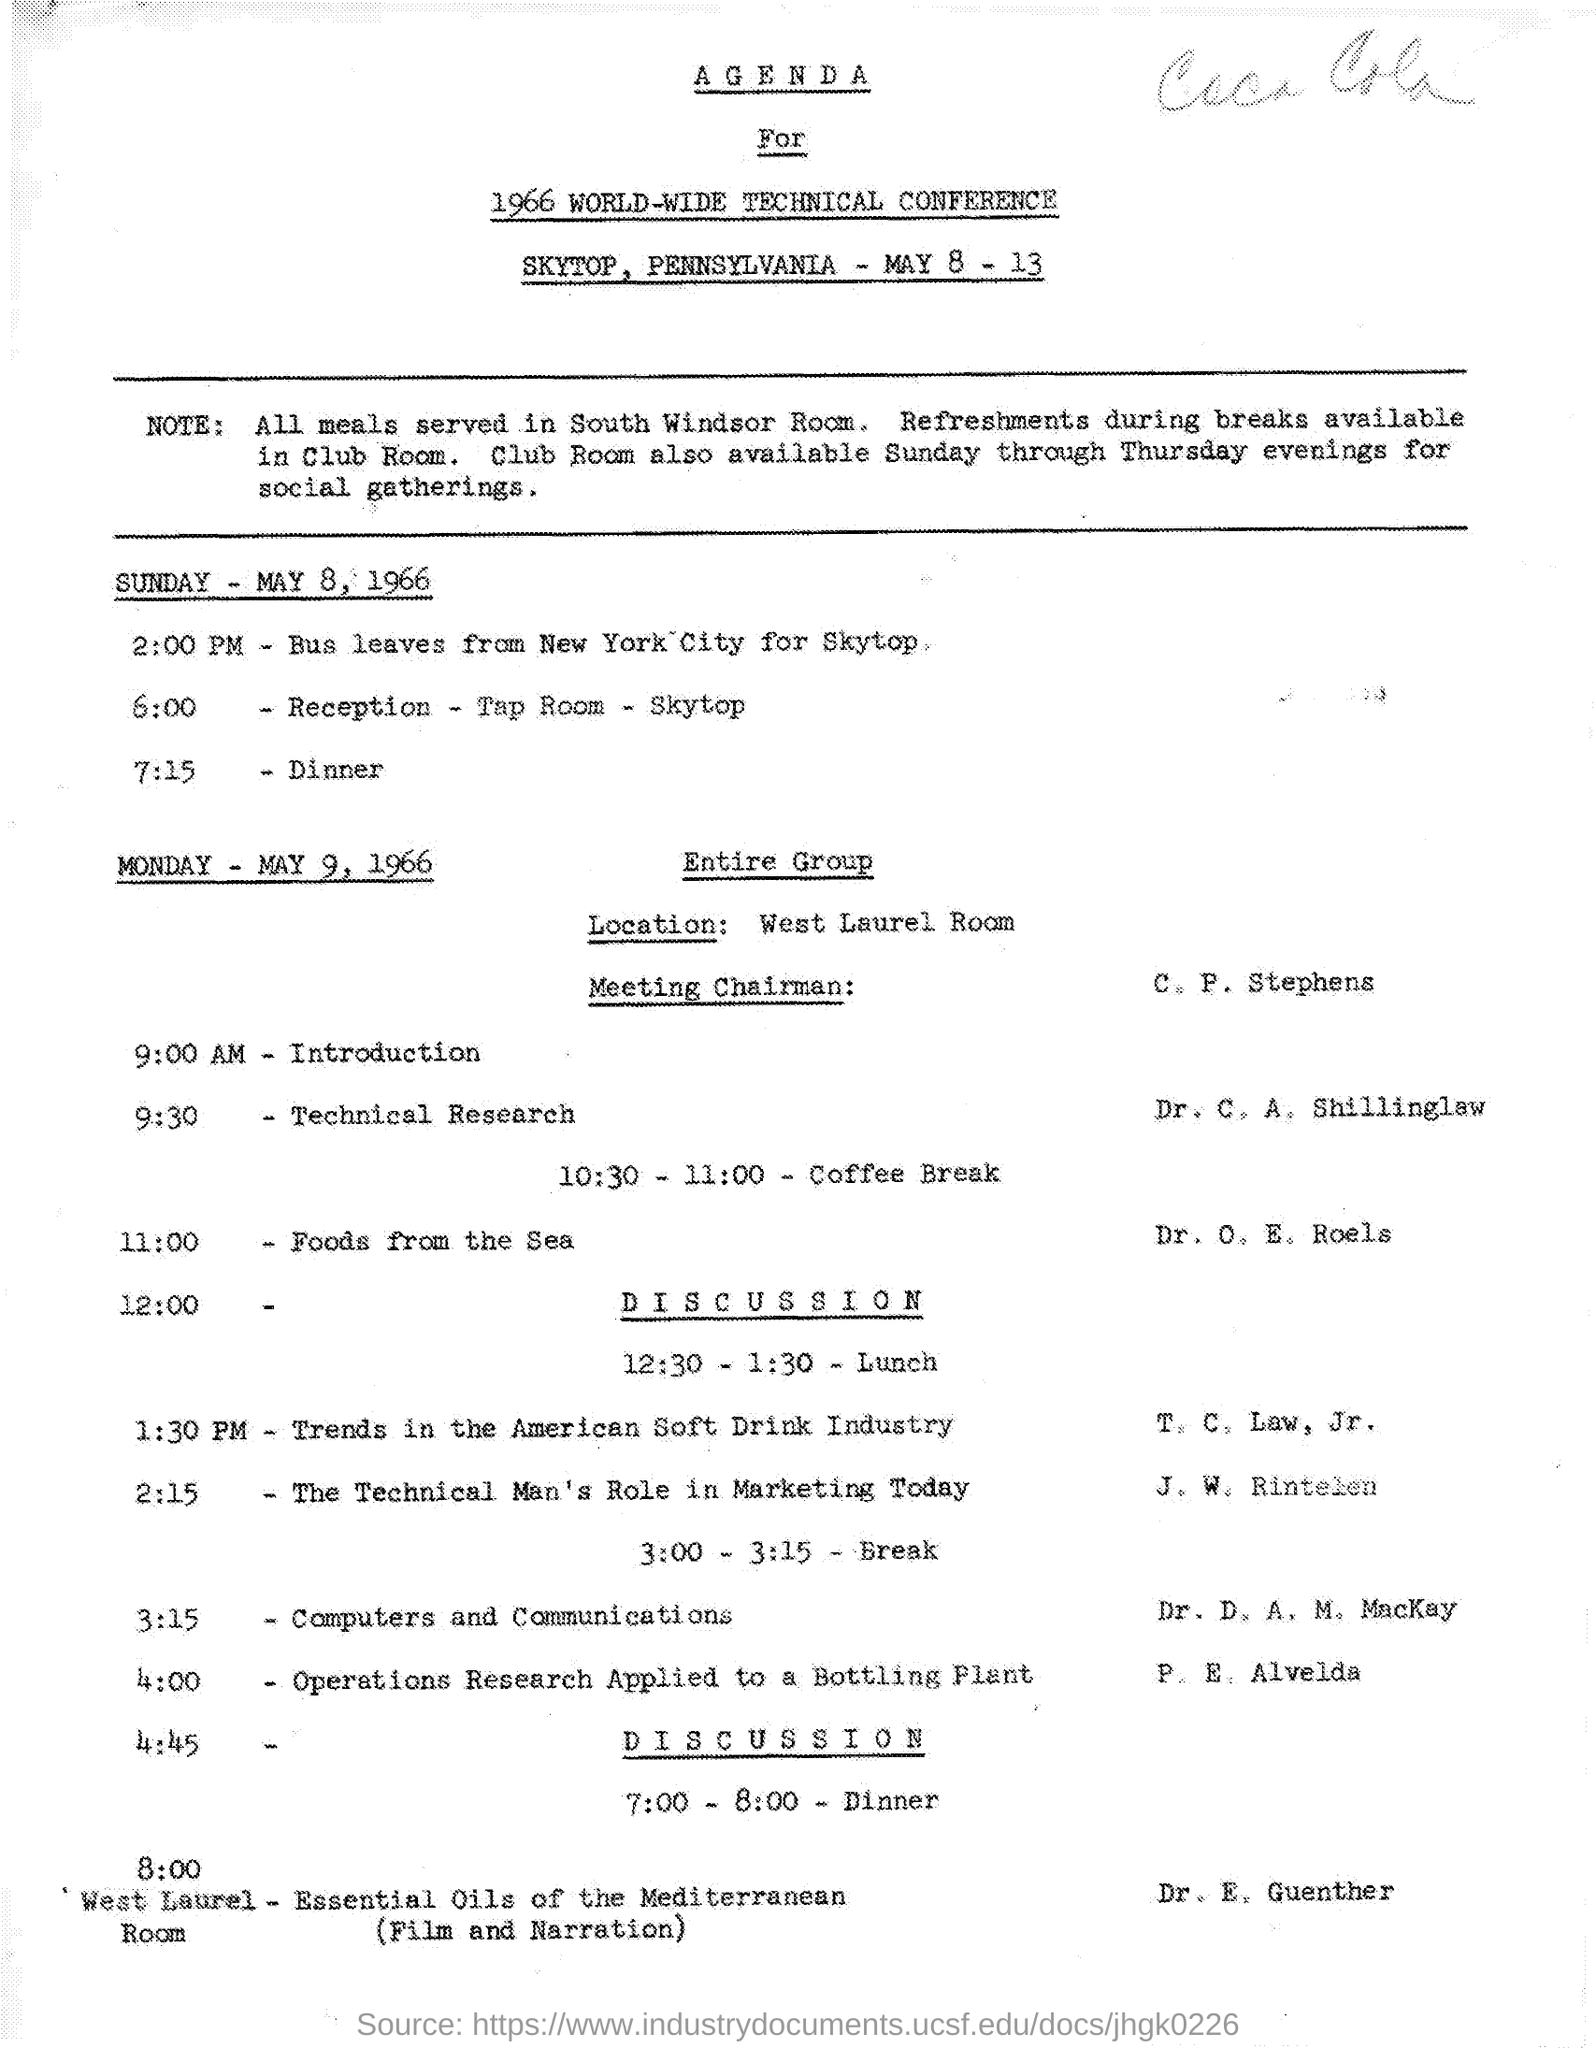Mention a couple of crucial points in this snapshot. The introduction will take place at 9:00 AM. The meals will be served in the south windsor room. On Sunday, May 8, 1966, dinner was at 7:15 PM. The coffee break is scheduled to occur between 10:30 and 11:00. 